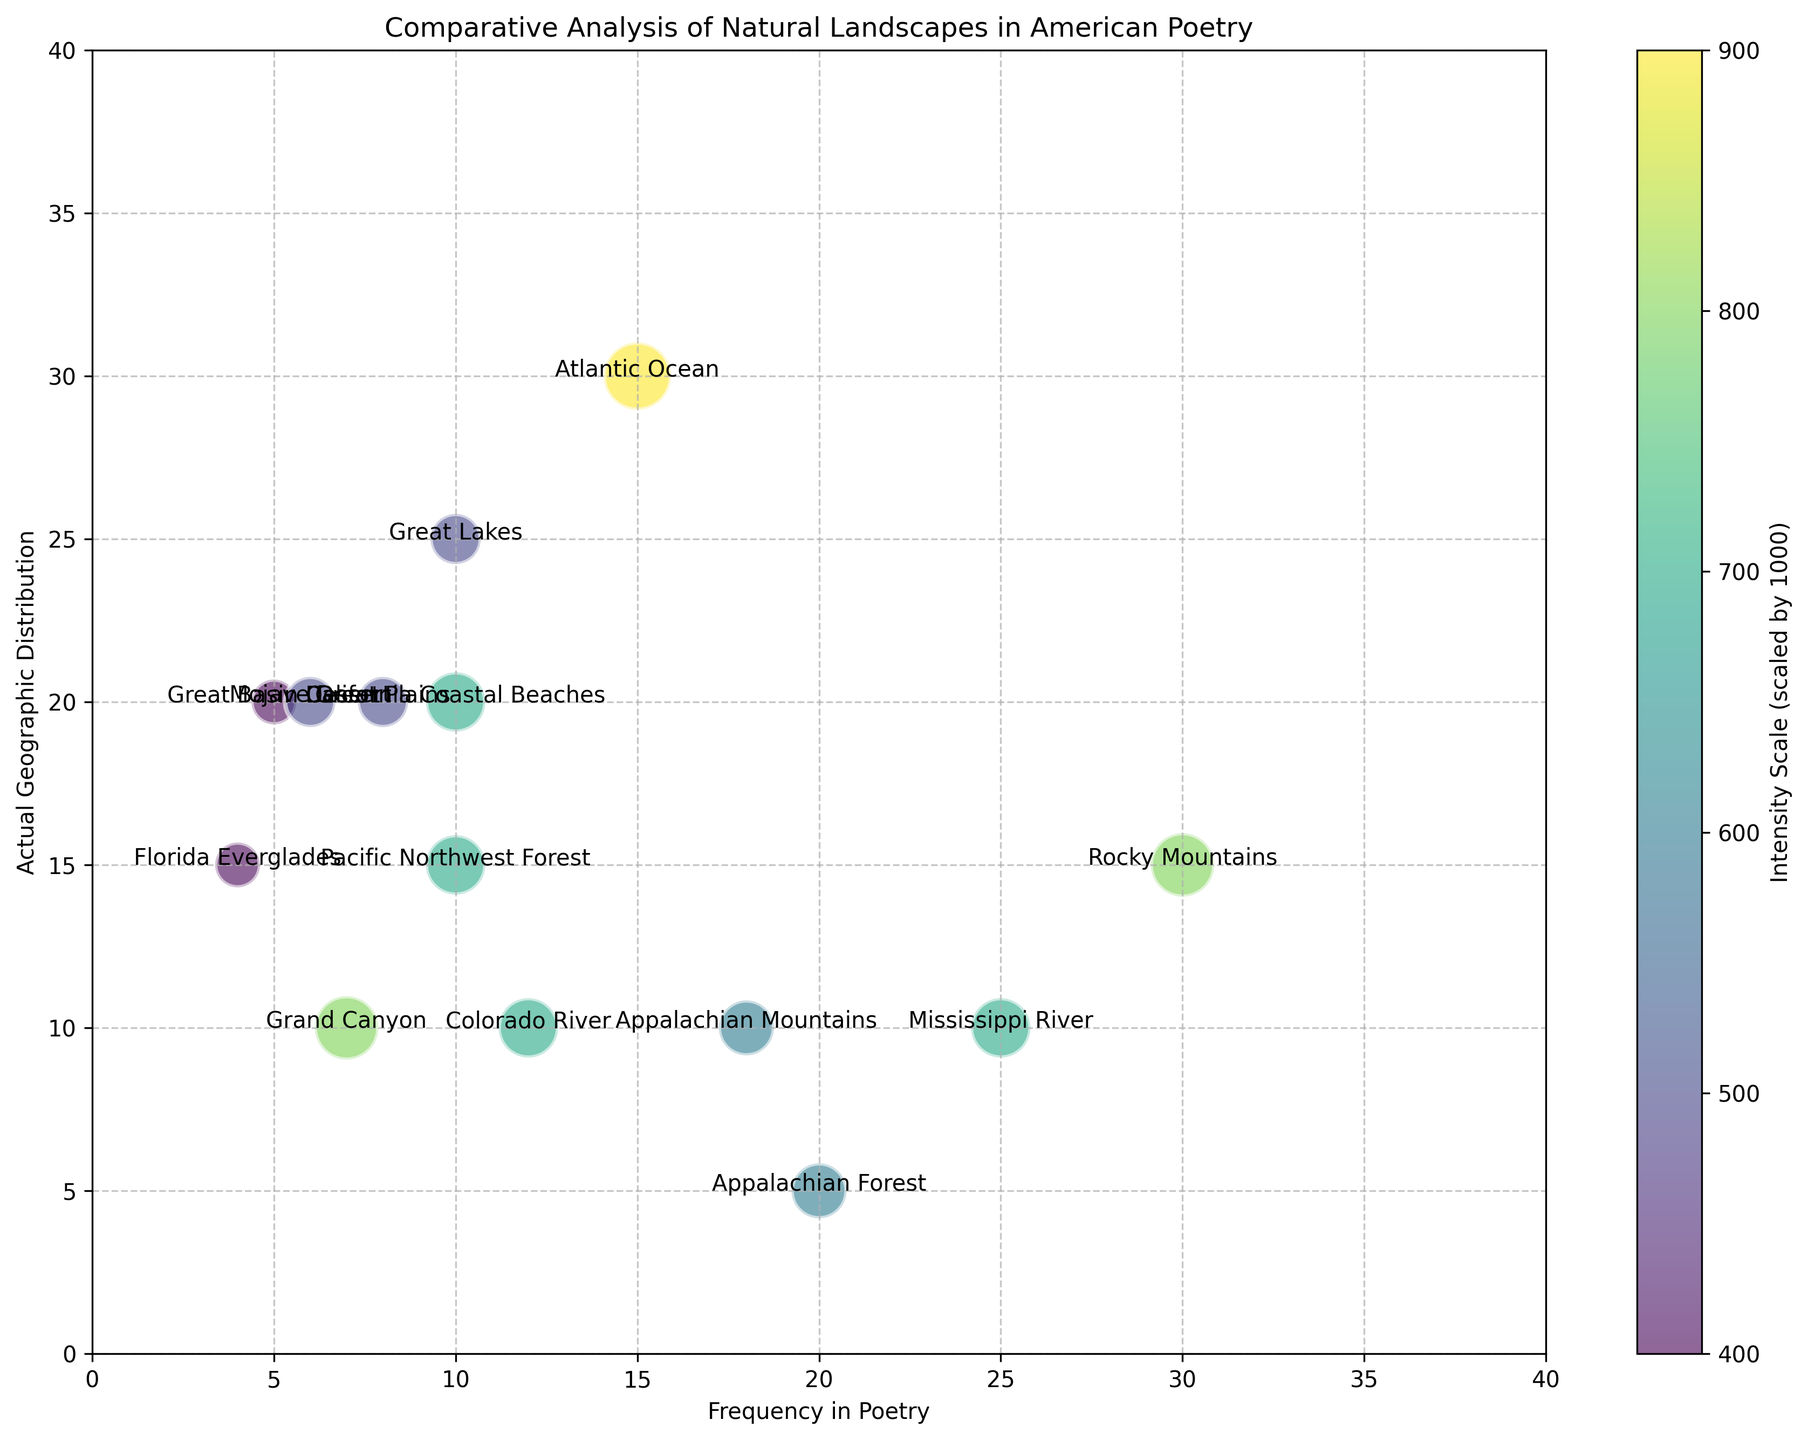What is the actual geographic distribution of the Appalachian Forest compared to its frequency in poetry? The Appalachian Forest has an actual geographic distribution of 5 and a frequency in poetry of 20.
Answer: Geographic distribution: 5, Frequency in poetry: 20 Which natural landscape type has the highest actual geographic distribution, and how does its frequency in poetry compare? The Atlantic Ocean has the highest actual geographic distribution of 30. Its frequency in poetry is 15, which is half of its geographic distribution.
Answer: Atlantic Ocean: Geographic distribution 30, Frequency in poetry 15 What is the sum of the geographic distributions of the Appalachian Mountains and the Grand Canyon? The Appalachian Mountains have a geographic distribution of 10, and the Grand Canyon has a geographic distribution of 10. Summing these up gives 10 + 10 = 20.
Answer: 20 Which landscape type described in poetry shows the greatest difference between its frequency in poetry and its actual geographic distribution? The Appalachian Forest shows the greatest difference, with a frequency in poetry of 20 and an actual geographic distribution of 5, making a difference of 15.
Answer: Appalachian Forest: Difference 15 How does the intensity of the California Coastal Beaches compare to that of the Mojave Desert? The intensity of the California Coastal Beaches is scaled at 0.7, while the Mojave Desert is scaled at 0.5. Therefore, the intensity of the California Coastal Beaches is higher.
Answer: California Coastal Beaches: 0.7, Mojave Desert: 0.5 Which two landscape types have the same intensity value of 0.7? The landscapes with an intensity value of 0.7 are the Mississippi River, Colorado River, California Coastal Beaches, and Pacific Northwest Forest.
Answer: Mississippi River, Colorado River, California Coastal Beaches, Pacific Northwest Forest What is the average frequency in poetry for the Rocky Mountains, Appalachian Mountains, and Great Plains? The Rocky Mountains have a frequency of 30, the Appalachian Mountains have a frequency of 18, and the Great Plains have a frequency of 8. The average frequency is calculated as (30 + 18 + 8) / 3 = 56 / 3 ≈ 18.67.
Answer: 18.67 For which landscape type is there an equal number of frequency in poetry and actual geographic distribution? The Colorado River has an equal frequency in poetry and actual geographic distribution, both being 10.
Answer: Colorado River 